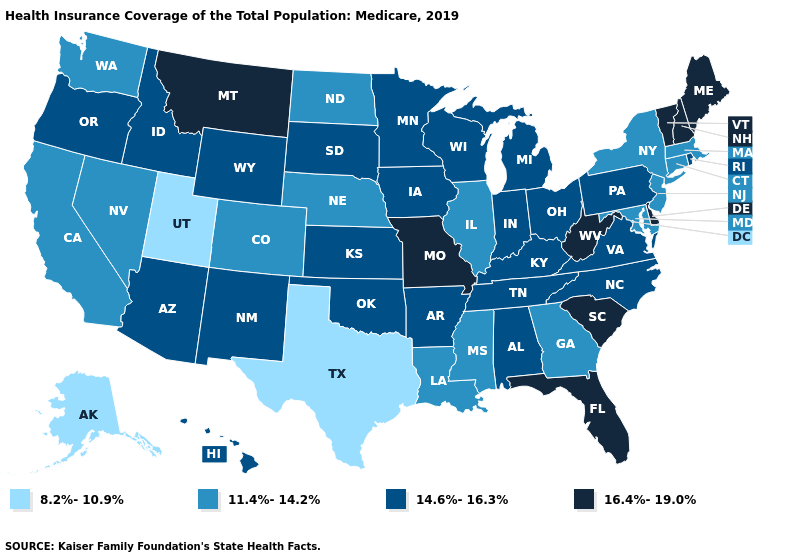Name the states that have a value in the range 11.4%-14.2%?
Quick response, please. California, Colorado, Connecticut, Georgia, Illinois, Louisiana, Maryland, Massachusetts, Mississippi, Nebraska, Nevada, New Jersey, New York, North Dakota, Washington. What is the highest value in the USA?
Concise answer only. 16.4%-19.0%. Does Delaware have the highest value in the USA?
Quick response, please. Yes. Name the states that have a value in the range 8.2%-10.9%?
Short answer required. Alaska, Texas, Utah. Which states hav the highest value in the West?
Keep it brief. Montana. Which states have the lowest value in the MidWest?
Quick response, please. Illinois, Nebraska, North Dakota. What is the value of New Mexico?
Quick response, please. 14.6%-16.3%. Name the states that have a value in the range 8.2%-10.9%?
Be succinct. Alaska, Texas, Utah. What is the lowest value in the USA?
Give a very brief answer. 8.2%-10.9%. Among the states that border Indiana , does Michigan have the highest value?
Keep it brief. Yes. Which states have the lowest value in the USA?
Quick response, please. Alaska, Texas, Utah. Among the states that border Ohio , which have the highest value?
Give a very brief answer. West Virginia. Among the states that border Indiana , does Illinois have the highest value?
Short answer required. No. Does the first symbol in the legend represent the smallest category?
Be succinct. Yes. Among the states that border Maine , which have the highest value?
Be succinct. New Hampshire. 